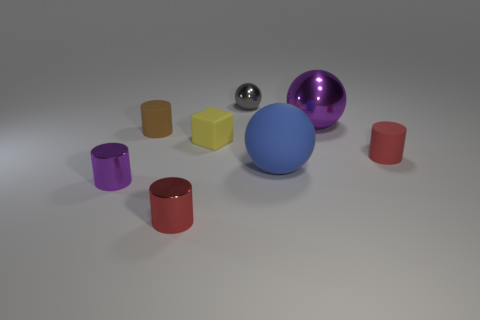Subtract all brown cylinders. How many cylinders are left? 3 Subtract all purple cylinders. How many cylinders are left? 3 Subtract all yellow cylinders. Subtract all blue blocks. How many cylinders are left? 4 Add 1 red things. How many objects exist? 9 Subtract all spheres. How many objects are left? 5 Add 6 big blue rubber spheres. How many big blue rubber spheres are left? 7 Add 3 large brown shiny blocks. How many large brown shiny blocks exist? 3 Subtract 1 purple balls. How many objects are left? 7 Subtract all big brown cylinders. Subtract all brown things. How many objects are left? 7 